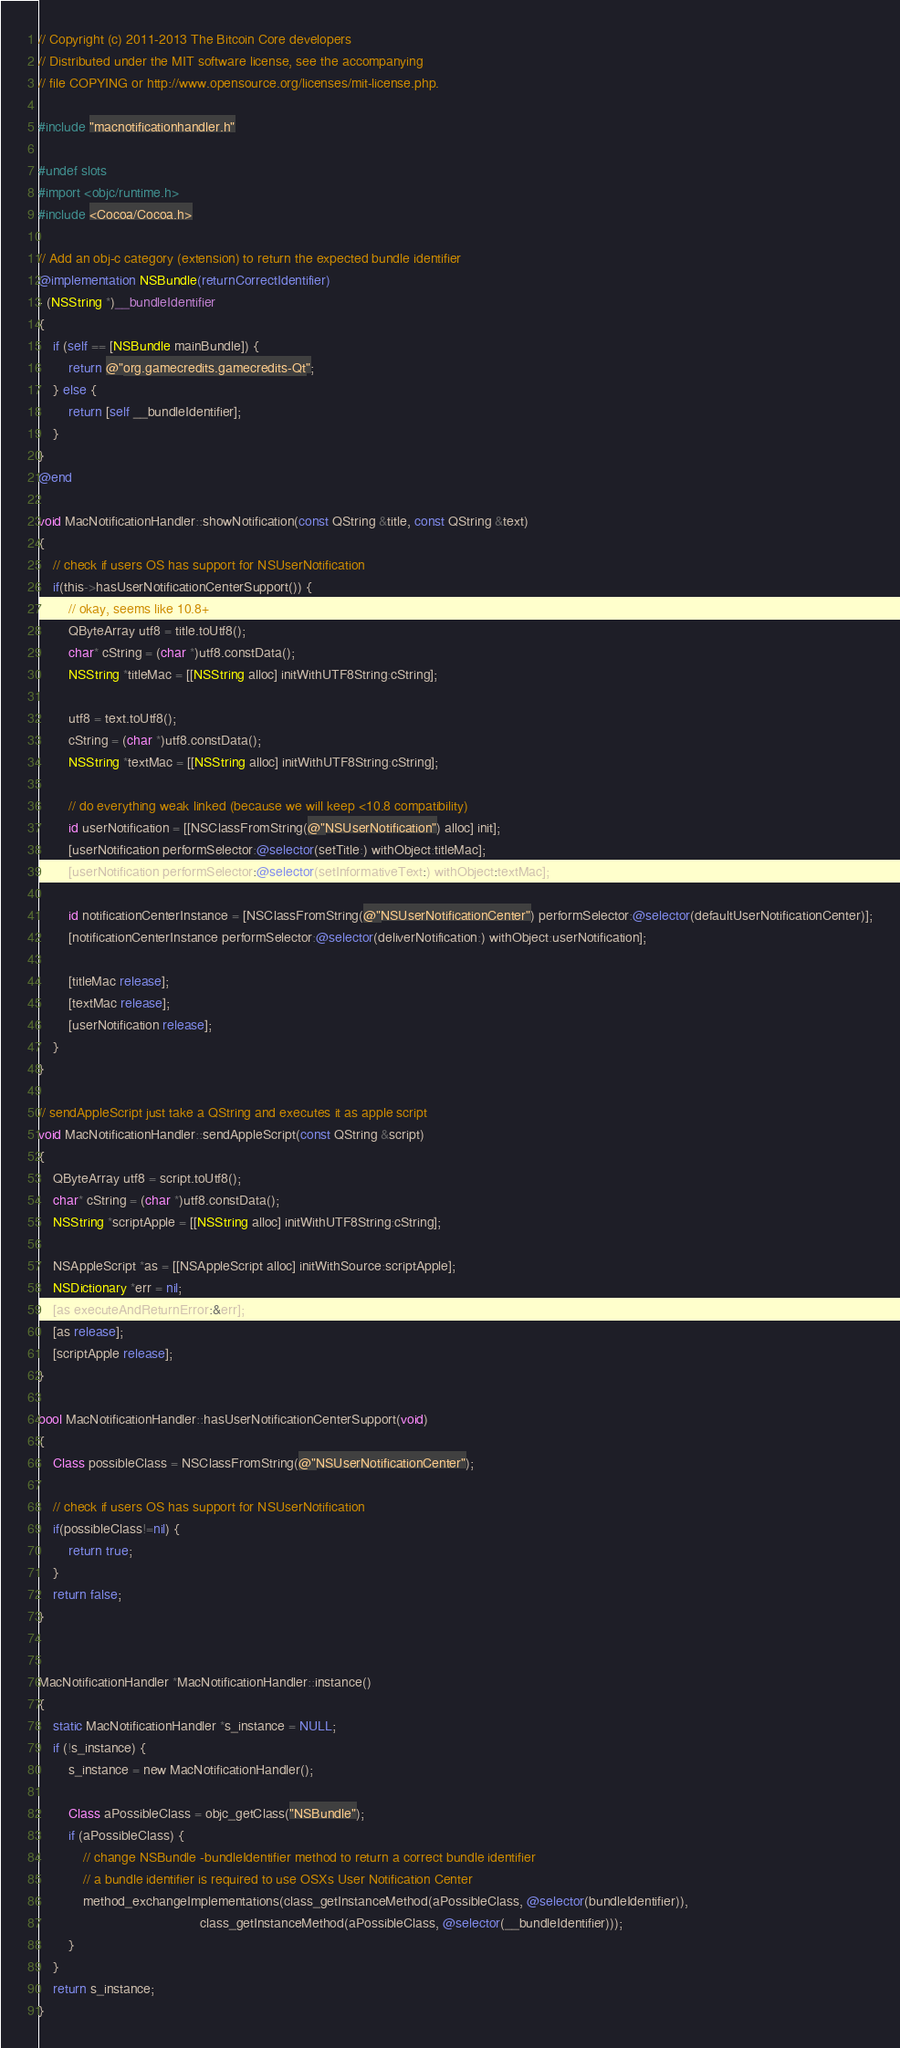<code> <loc_0><loc_0><loc_500><loc_500><_ObjectiveC_>// Copyright (c) 2011-2013 The Bitcoin Core developers
// Distributed under the MIT software license, see the accompanying
// file COPYING or http://www.opensource.org/licenses/mit-license.php.

#include "macnotificationhandler.h"

#undef slots
#import <objc/runtime.h>
#include <Cocoa/Cocoa.h>

// Add an obj-c category (extension) to return the expected bundle identifier
@implementation NSBundle(returnCorrectIdentifier)
- (NSString *)__bundleIdentifier
{
    if (self == [NSBundle mainBundle]) {
        return @"org.gamecredits.gamecredits-Qt";
    } else {
        return [self __bundleIdentifier];
    }
}
@end

void MacNotificationHandler::showNotification(const QString &title, const QString &text)
{
    // check if users OS has support for NSUserNotification
    if(this->hasUserNotificationCenterSupport()) {
        // okay, seems like 10.8+
        QByteArray utf8 = title.toUtf8();
        char* cString = (char *)utf8.constData();
        NSString *titleMac = [[NSString alloc] initWithUTF8String:cString];

        utf8 = text.toUtf8();
        cString = (char *)utf8.constData();
        NSString *textMac = [[NSString alloc] initWithUTF8String:cString];

        // do everything weak linked (because we will keep <10.8 compatibility)
        id userNotification = [[NSClassFromString(@"NSUserNotification") alloc] init];
        [userNotification performSelector:@selector(setTitle:) withObject:titleMac];
        [userNotification performSelector:@selector(setInformativeText:) withObject:textMac];

        id notificationCenterInstance = [NSClassFromString(@"NSUserNotificationCenter") performSelector:@selector(defaultUserNotificationCenter)];
        [notificationCenterInstance performSelector:@selector(deliverNotification:) withObject:userNotification];

        [titleMac release];
        [textMac release];
        [userNotification release];
    }
}

// sendAppleScript just take a QString and executes it as apple script
void MacNotificationHandler::sendAppleScript(const QString &script)
{
    QByteArray utf8 = script.toUtf8();
    char* cString = (char *)utf8.constData();
    NSString *scriptApple = [[NSString alloc] initWithUTF8String:cString];

    NSAppleScript *as = [[NSAppleScript alloc] initWithSource:scriptApple];
    NSDictionary *err = nil;
    [as executeAndReturnError:&err];
    [as release];
    [scriptApple release];
}

bool MacNotificationHandler::hasUserNotificationCenterSupport(void)
{
    Class possibleClass = NSClassFromString(@"NSUserNotificationCenter");

    // check if users OS has support for NSUserNotification
    if(possibleClass!=nil) {
        return true;
    }
    return false;
}


MacNotificationHandler *MacNotificationHandler::instance()
{
    static MacNotificationHandler *s_instance = NULL;
    if (!s_instance) {
        s_instance = new MacNotificationHandler();
        
        Class aPossibleClass = objc_getClass("NSBundle");
        if (aPossibleClass) {
            // change NSBundle -bundleIdentifier method to return a correct bundle identifier
            // a bundle identifier is required to use OSXs User Notification Center
            method_exchangeImplementations(class_getInstanceMethod(aPossibleClass, @selector(bundleIdentifier)),
                                           class_getInstanceMethod(aPossibleClass, @selector(__bundleIdentifier)));
        }
    }
    return s_instance;
}
</code> 